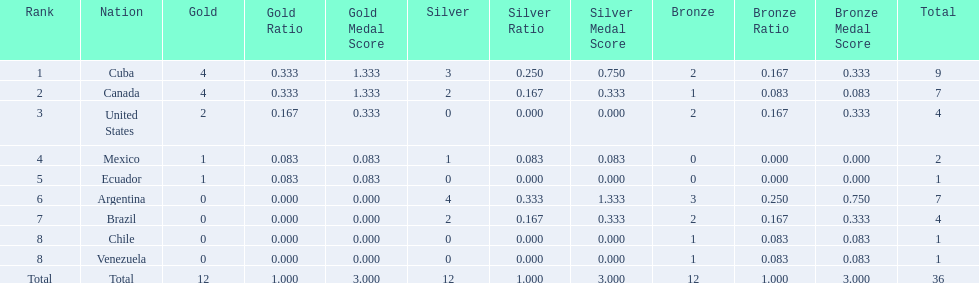What were all of the nations involved in the canoeing at the 2011 pan american games? Cuba, Canada, United States, Mexico, Ecuador, Argentina, Brazil, Chile, Venezuela, Total. Of these, which had a numbered rank? Cuba, Canada, United States, Mexico, Ecuador, Argentina, Brazil, Chile, Venezuela. From these, which had the highest number of bronze? Argentina. 